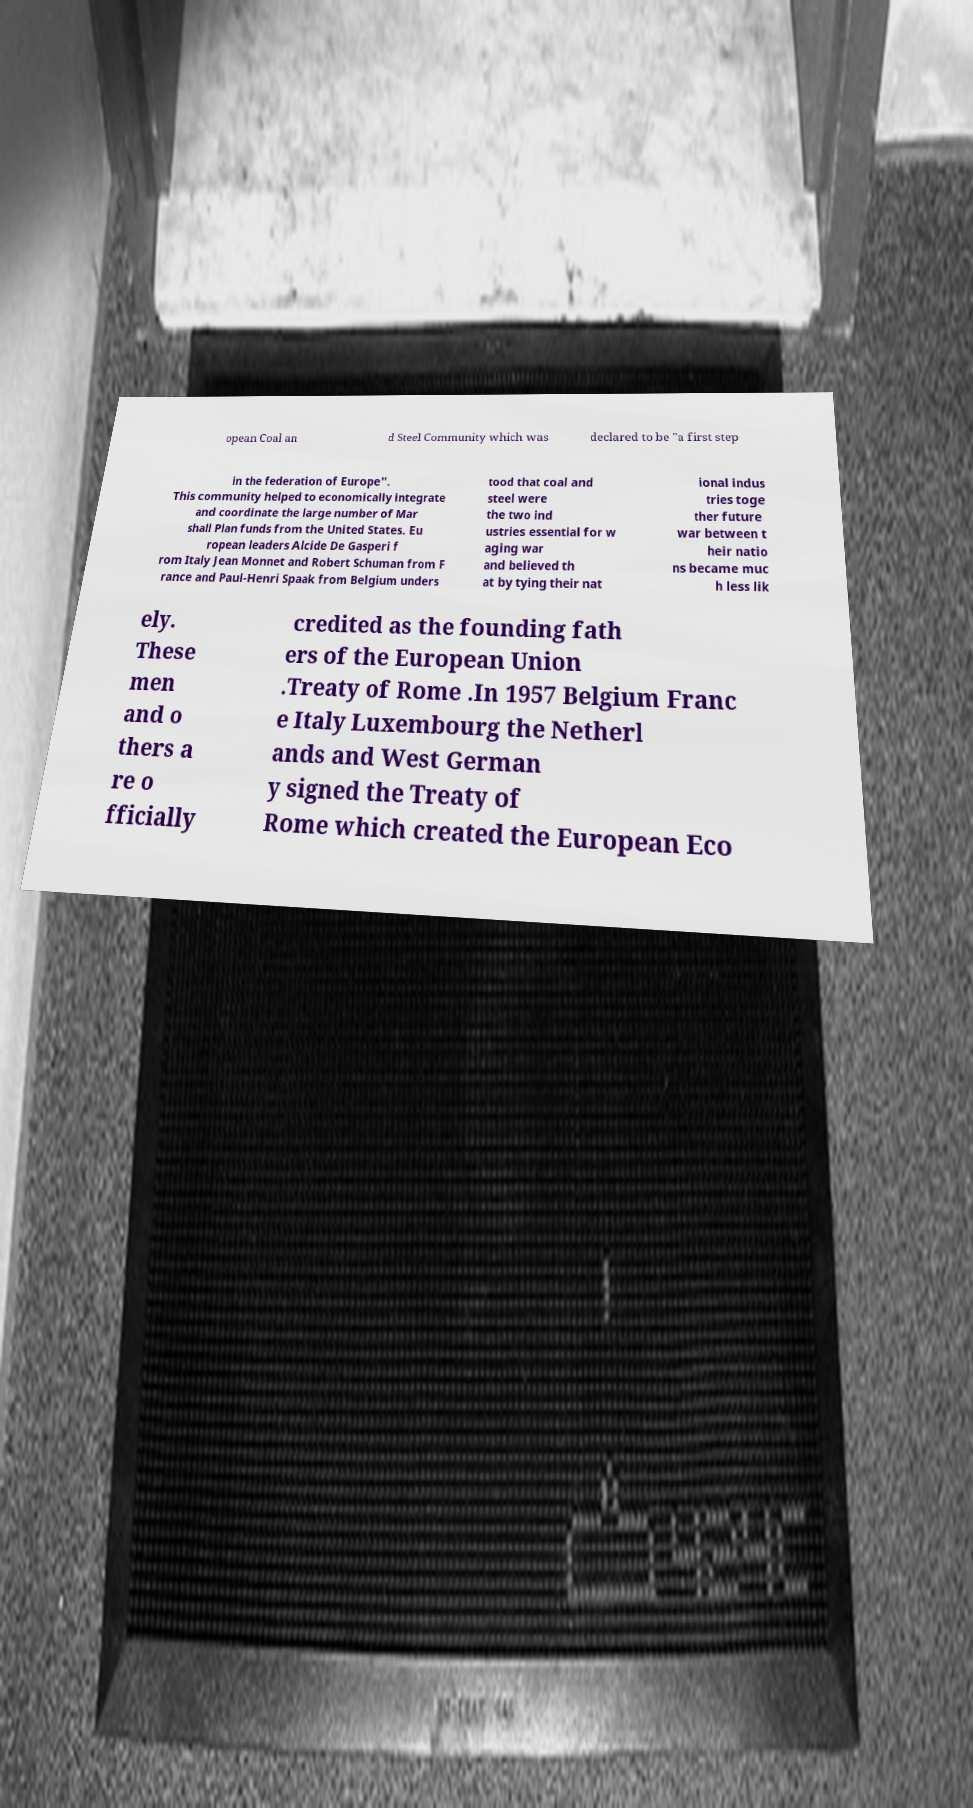I need the written content from this picture converted into text. Can you do that? opean Coal an d Steel Community which was declared to be "a first step in the federation of Europe". This community helped to economically integrate and coordinate the large number of Mar shall Plan funds from the United States. Eu ropean leaders Alcide De Gasperi f rom Italy Jean Monnet and Robert Schuman from F rance and Paul-Henri Spaak from Belgium unders tood that coal and steel were the two ind ustries essential for w aging war and believed th at by tying their nat ional indus tries toge ther future war between t heir natio ns became muc h less lik ely. These men and o thers a re o fficially credited as the founding fath ers of the European Union .Treaty of Rome .In 1957 Belgium Franc e Italy Luxembourg the Netherl ands and West German y signed the Treaty of Rome which created the European Eco 